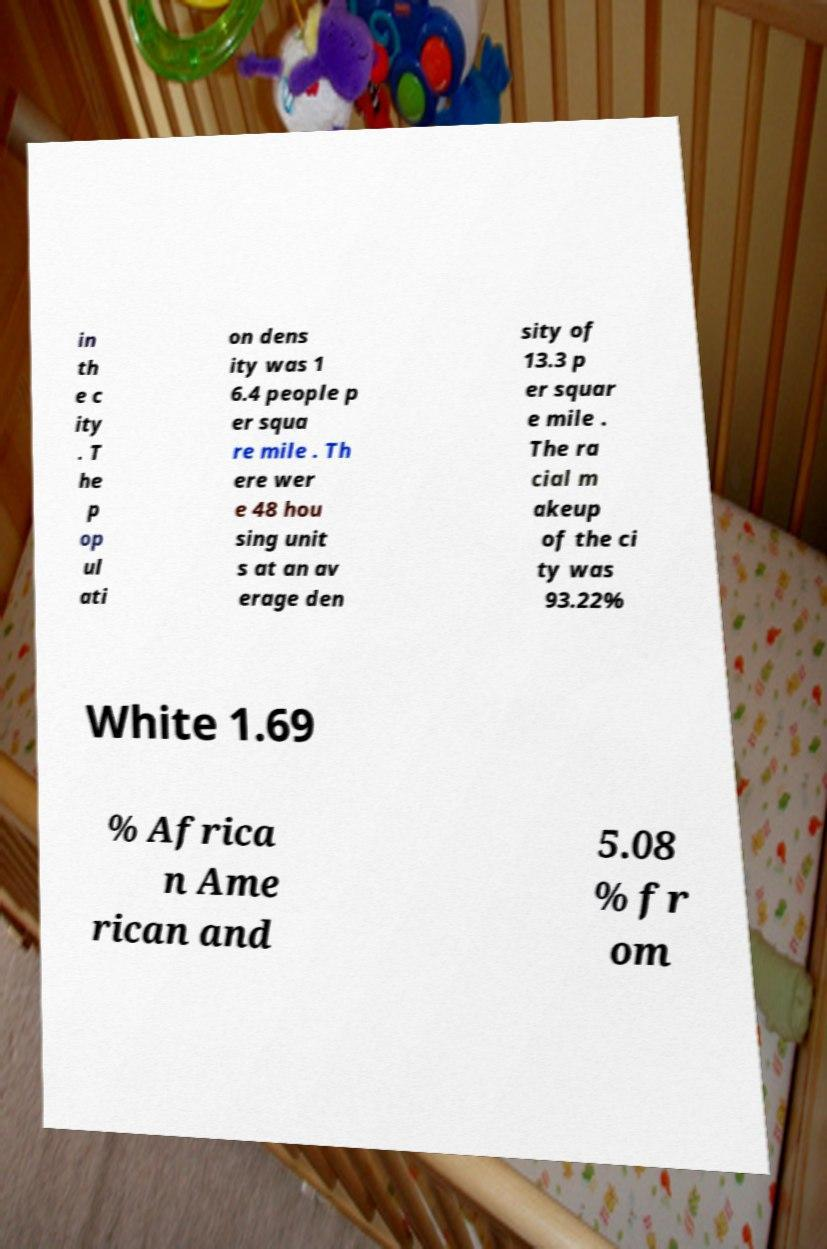Could you assist in decoding the text presented in this image and type it out clearly? in th e c ity . T he p op ul ati on dens ity was 1 6.4 people p er squa re mile . Th ere wer e 48 hou sing unit s at an av erage den sity of 13.3 p er squar e mile . The ra cial m akeup of the ci ty was 93.22% White 1.69 % Africa n Ame rican and 5.08 % fr om 